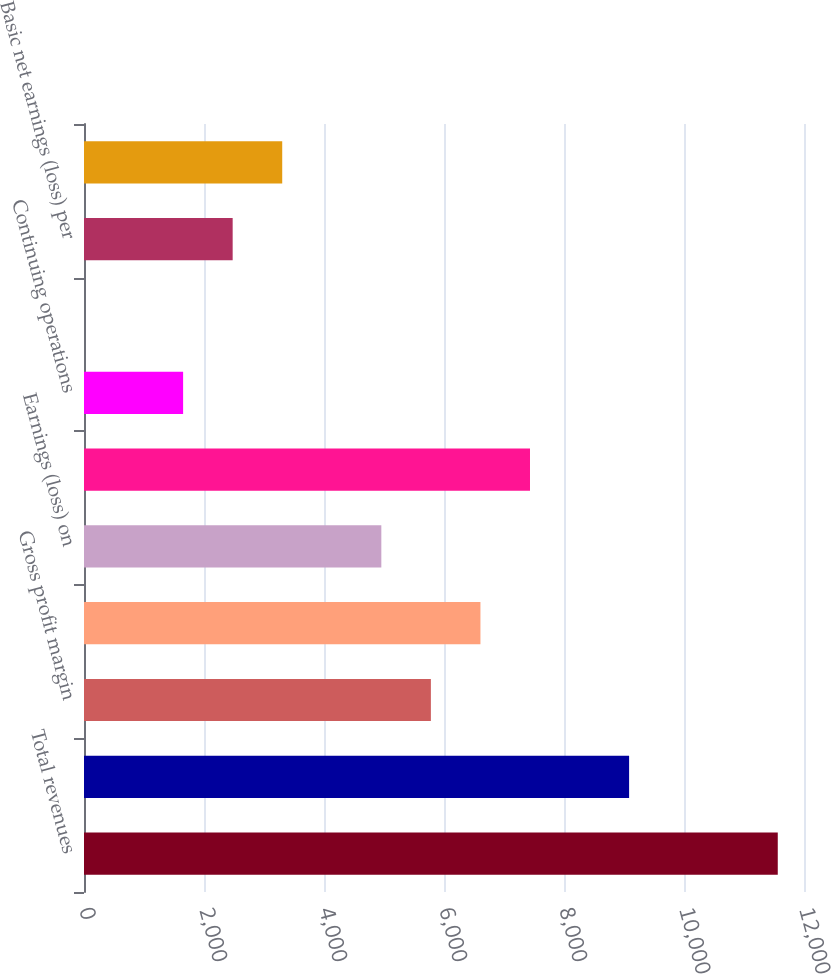<chart> <loc_0><loc_0><loc_500><loc_500><bar_chart><fcel>Total revenues<fcel>Gross profit<fcel>Gross profit margin<fcel>Earnings (loss) from<fcel>Earnings (loss) on<fcel>Net earnings (loss)<fcel>Continuing operations<fcel>Discontinued operations<fcel>Basic net earnings (loss) per<fcel>Diluted net earnings (loss)<nl><fcel>11562.8<fcel>9085.04<fcel>5781.4<fcel>6607.31<fcel>4955.49<fcel>7433.22<fcel>1651.85<fcel>0.03<fcel>2477.76<fcel>3303.67<nl></chart> 